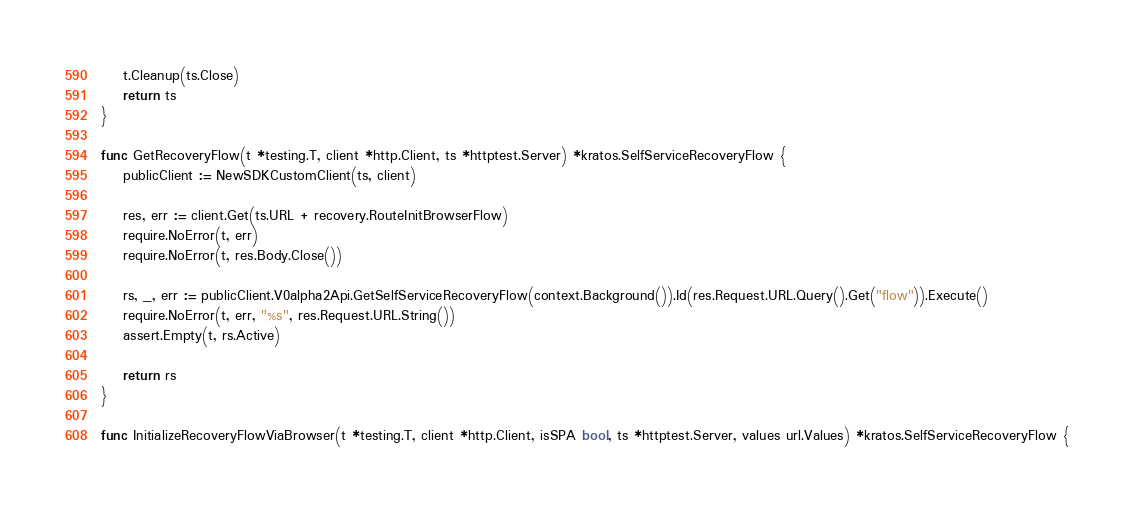<code> <loc_0><loc_0><loc_500><loc_500><_Go_>	t.Cleanup(ts.Close)
	return ts
}

func GetRecoveryFlow(t *testing.T, client *http.Client, ts *httptest.Server) *kratos.SelfServiceRecoveryFlow {
	publicClient := NewSDKCustomClient(ts, client)

	res, err := client.Get(ts.URL + recovery.RouteInitBrowserFlow)
	require.NoError(t, err)
	require.NoError(t, res.Body.Close())

	rs, _, err := publicClient.V0alpha2Api.GetSelfServiceRecoveryFlow(context.Background()).Id(res.Request.URL.Query().Get("flow")).Execute()
	require.NoError(t, err, "%s", res.Request.URL.String())
	assert.Empty(t, rs.Active)

	return rs
}

func InitializeRecoveryFlowViaBrowser(t *testing.T, client *http.Client, isSPA bool, ts *httptest.Server, values url.Values) *kratos.SelfServiceRecoveryFlow {</code> 